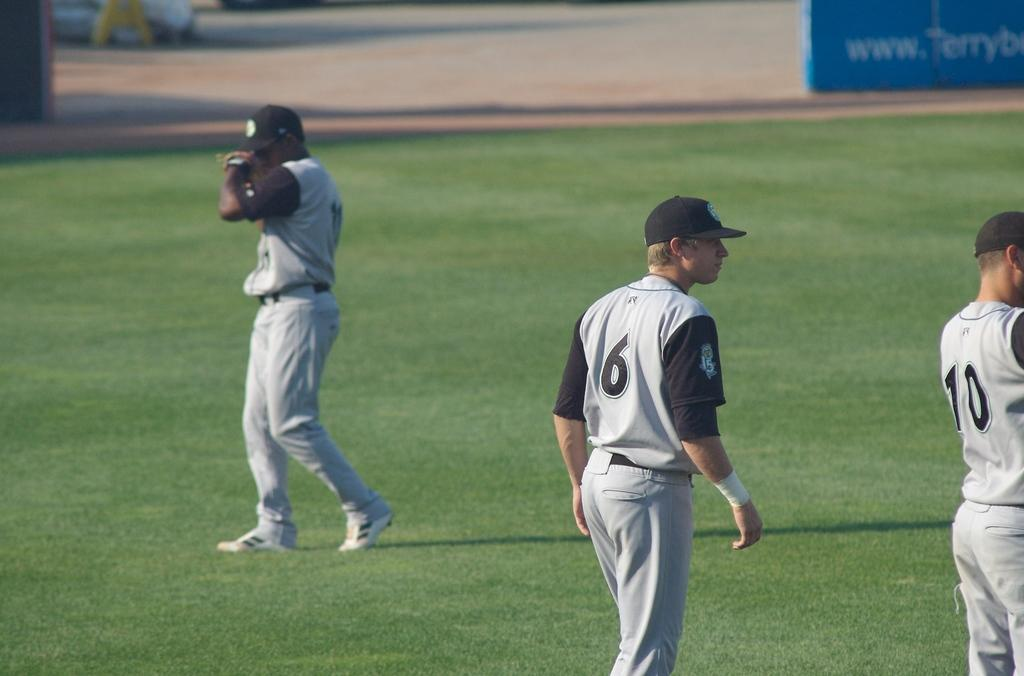<image>
Give a short and clear explanation of the subsequent image. Baseball players on a field, one with the number 6 and the other with the number 10 